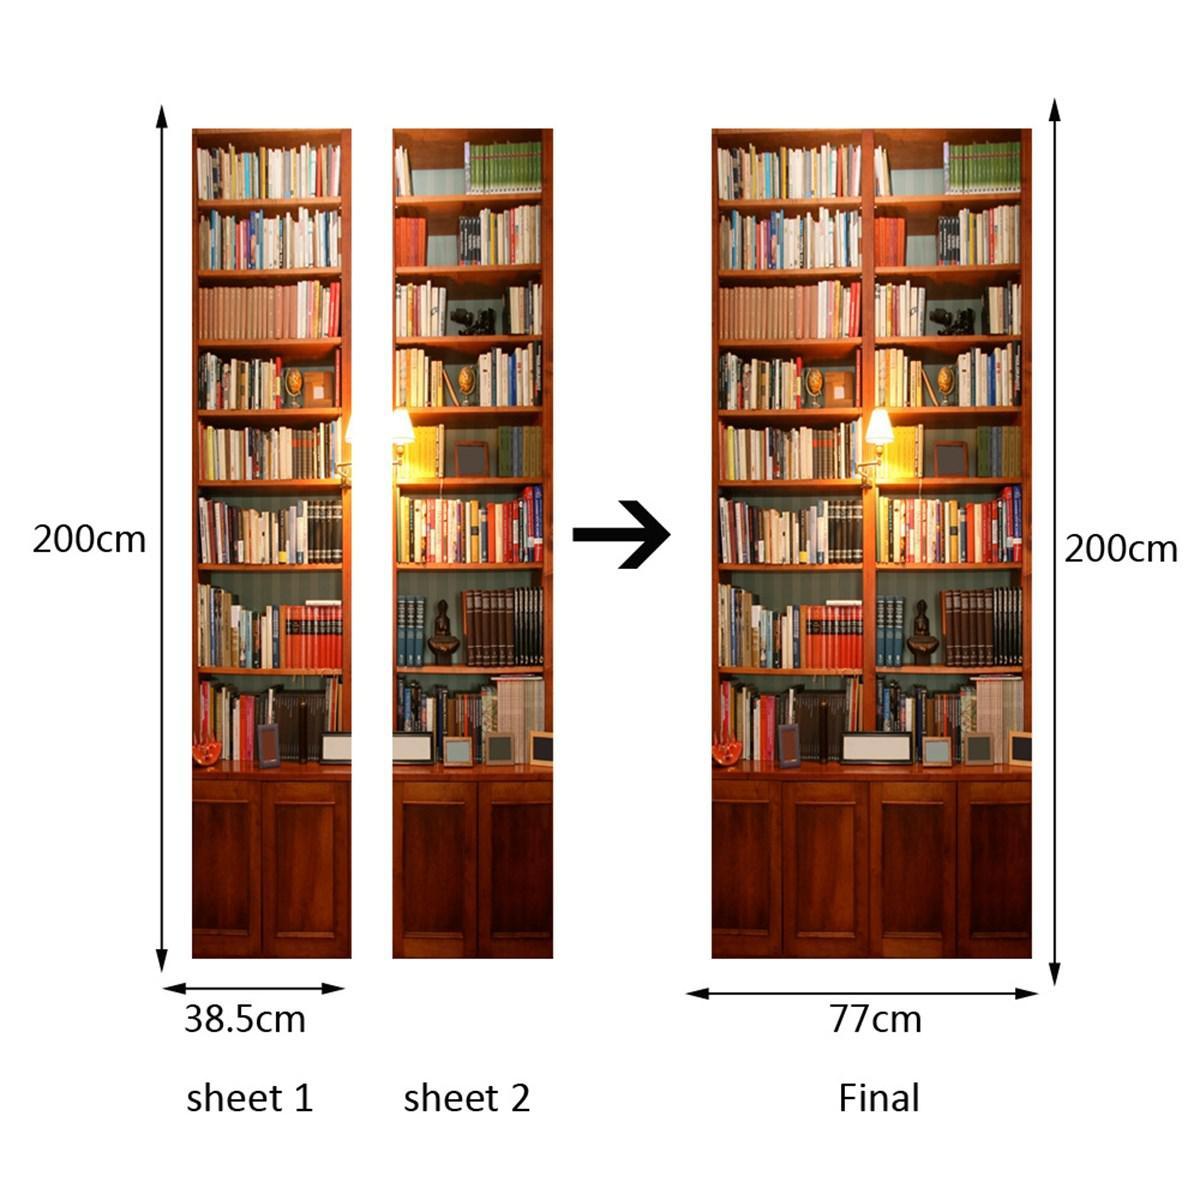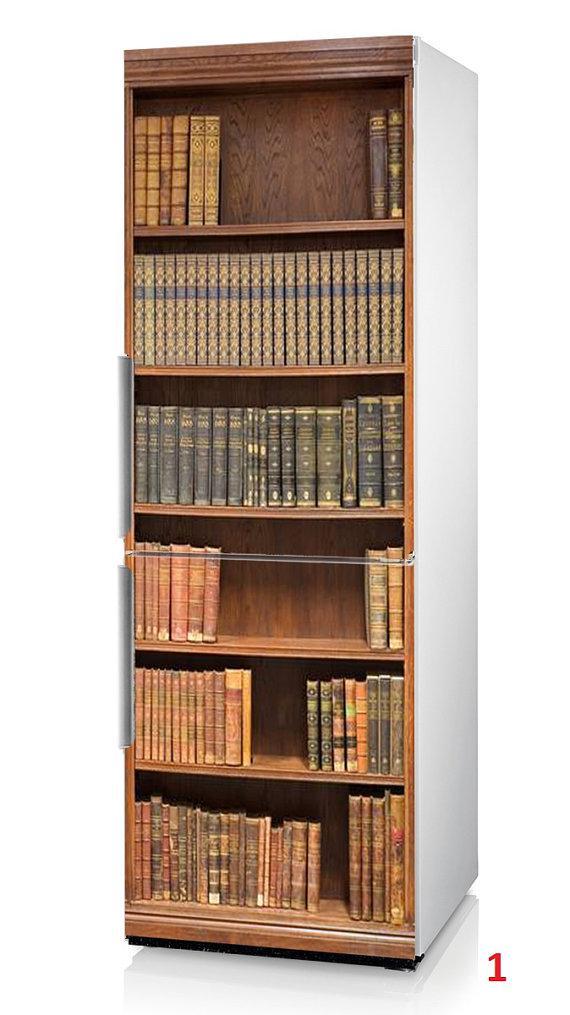The first image is the image on the left, the second image is the image on the right. Evaluate the accuracy of this statement regarding the images: "At least one image features a bookcase with reddish-brown panels at the bottom and eight vertical shelves.". Is it true? Answer yes or no. Yes. The first image is the image on the left, the second image is the image on the right. For the images shown, is this caption "An object is next to one of the bookcases." true? Answer yes or no. No. 